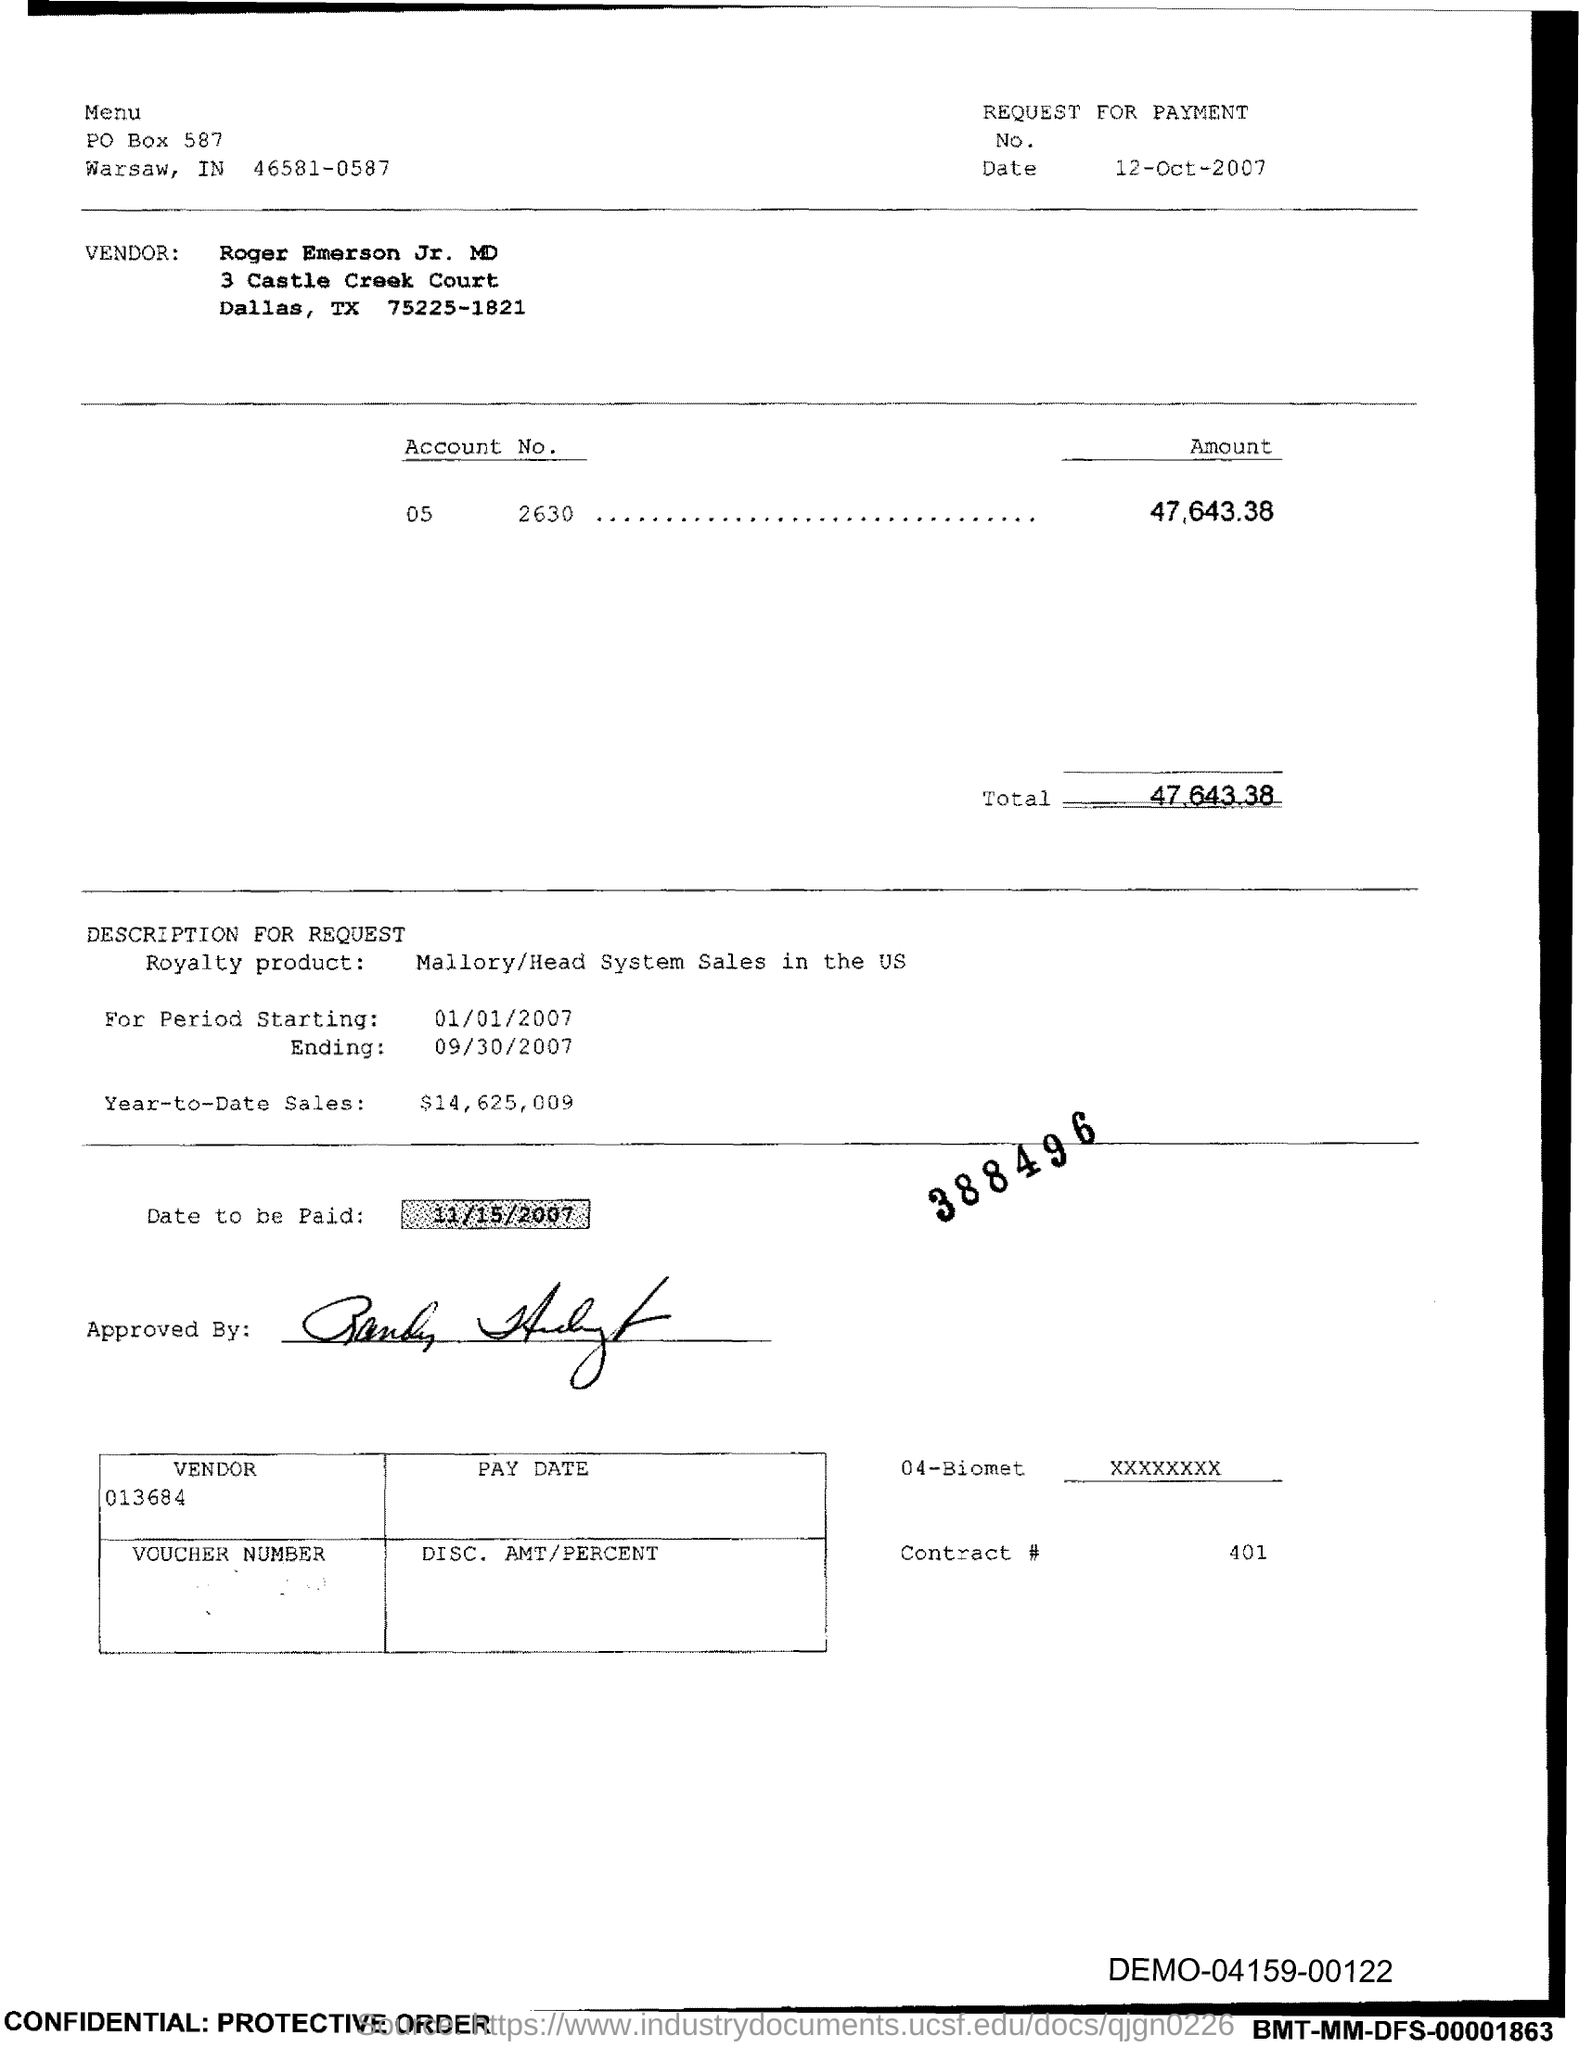Identify some key points in this picture. Please provide the Contract # Number as 401... The PO Box number mentioned in the document is 587. The total is 47,643.38. 